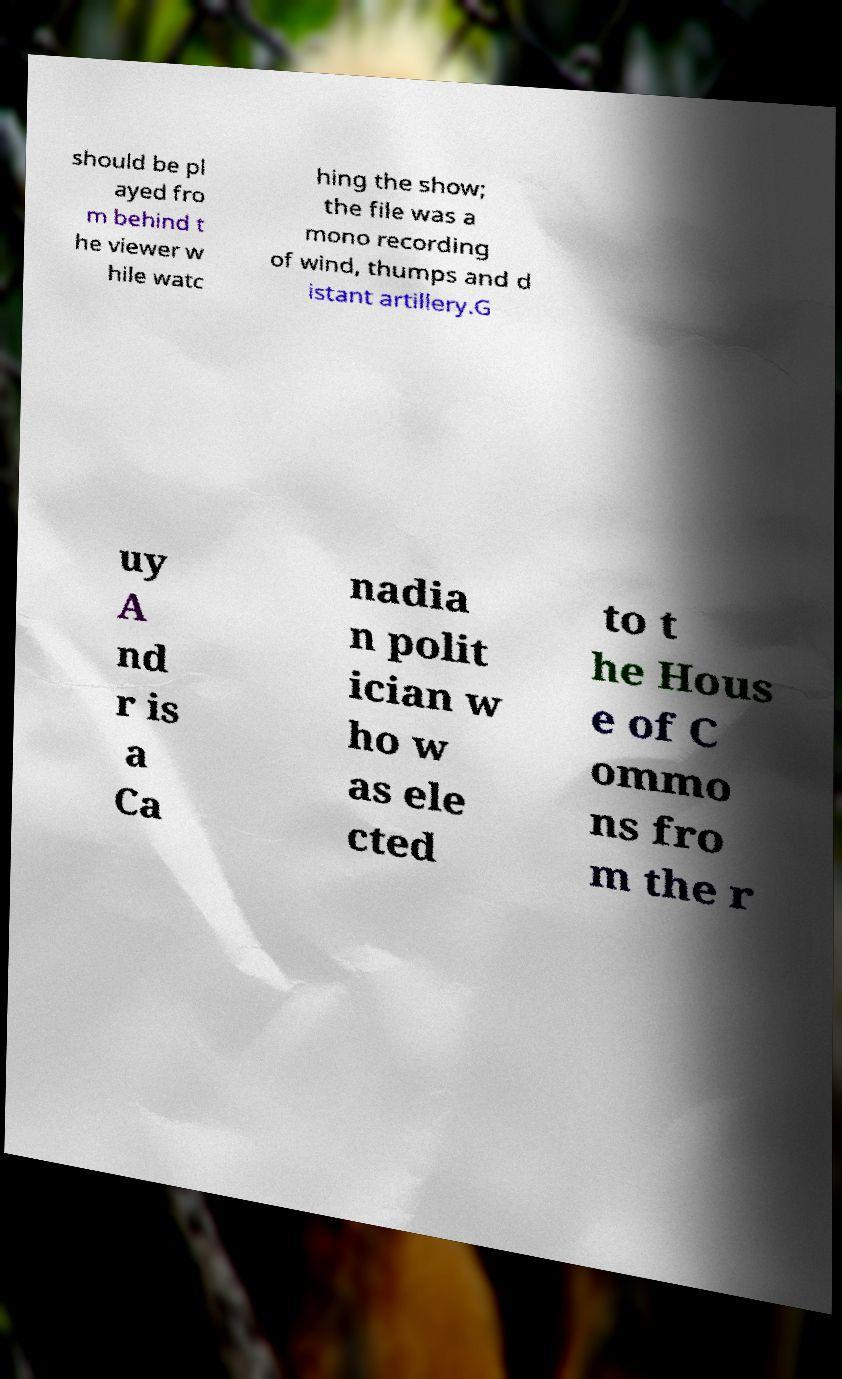Could you assist in decoding the text presented in this image and type it out clearly? should be pl ayed fro m behind t he viewer w hile watc hing the show; the file was a mono recording of wind, thumps and d istant artillery.G uy A nd r is a Ca nadia n polit ician w ho w as ele cted to t he Hous e of C ommo ns fro m the r 